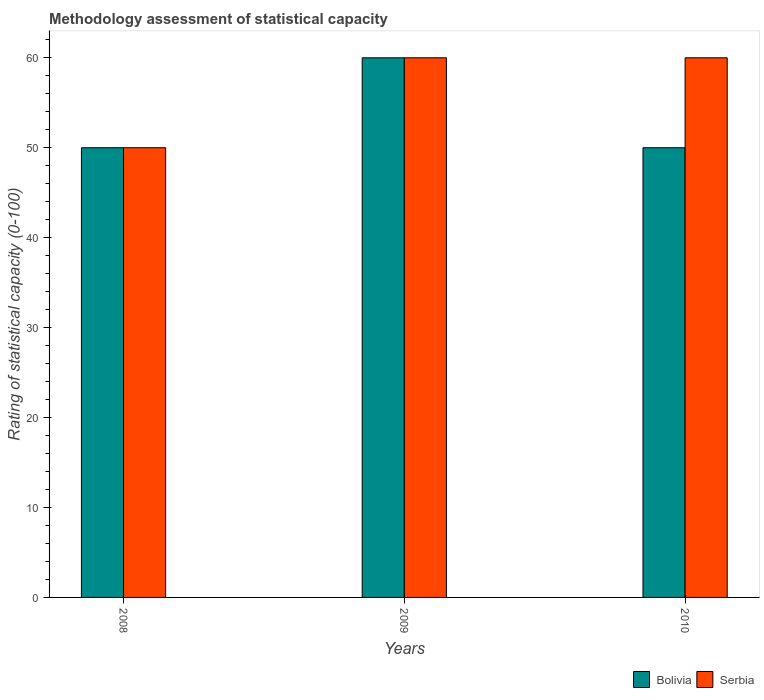How many bars are there on the 1st tick from the left?
Your answer should be very brief. 2. What is the label of the 3rd group of bars from the left?
Your response must be concise. 2010. In how many cases, is the number of bars for a given year not equal to the number of legend labels?
Provide a succinct answer. 0. What is the rating of statistical capacity in Bolivia in 2008?
Your answer should be compact. 50. Across all years, what is the maximum rating of statistical capacity in Bolivia?
Your response must be concise. 60. Across all years, what is the minimum rating of statistical capacity in Serbia?
Give a very brief answer. 50. In which year was the rating of statistical capacity in Serbia maximum?
Offer a terse response. 2009. What is the total rating of statistical capacity in Bolivia in the graph?
Give a very brief answer. 160. What is the difference between the rating of statistical capacity in Bolivia in 2008 and the rating of statistical capacity in Serbia in 2009?
Provide a succinct answer. -10. What is the average rating of statistical capacity in Serbia per year?
Provide a succinct answer. 56.67. In the year 2010, what is the difference between the rating of statistical capacity in Bolivia and rating of statistical capacity in Serbia?
Offer a very short reply. -10. What is the ratio of the rating of statistical capacity in Serbia in 2009 to that in 2010?
Ensure brevity in your answer.  1. Is the rating of statistical capacity in Bolivia in 2008 less than that in 2009?
Offer a terse response. Yes. What is the difference between the highest and the lowest rating of statistical capacity in Serbia?
Provide a succinct answer. 10. Is the sum of the rating of statistical capacity in Serbia in 2008 and 2009 greater than the maximum rating of statistical capacity in Bolivia across all years?
Make the answer very short. Yes. What does the 1st bar from the left in 2009 represents?
Provide a short and direct response. Bolivia. What does the 1st bar from the right in 2010 represents?
Your answer should be compact. Serbia. How many years are there in the graph?
Ensure brevity in your answer.  3. What is the difference between two consecutive major ticks on the Y-axis?
Provide a short and direct response. 10. Does the graph contain any zero values?
Your response must be concise. No. Where does the legend appear in the graph?
Make the answer very short. Bottom right. How many legend labels are there?
Your answer should be compact. 2. How are the legend labels stacked?
Ensure brevity in your answer.  Horizontal. What is the title of the graph?
Ensure brevity in your answer.  Methodology assessment of statistical capacity. Does "Least developed countries" appear as one of the legend labels in the graph?
Give a very brief answer. No. What is the label or title of the X-axis?
Your answer should be compact. Years. What is the label or title of the Y-axis?
Offer a very short reply. Rating of statistical capacity (0-100). What is the Rating of statistical capacity (0-100) in Bolivia in 2008?
Give a very brief answer. 50. Across all years, what is the maximum Rating of statistical capacity (0-100) in Serbia?
Offer a very short reply. 60. Across all years, what is the minimum Rating of statistical capacity (0-100) of Bolivia?
Make the answer very short. 50. What is the total Rating of statistical capacity (0-100) in Bolivia in the graph?
Keep it short and to the point. 160. What is the total Rating of statistical capacity (0-100) in Serbia in the graph?
Offer a very short reply. 170. What is the difference between the Rating of statistical capacity (0-100) in Serbia in 2008 and that in 2009?
Offer a terse response. -10. What is the difference between the Rating of statistical capacity (0-100) in Serbia in 2008 and that in 2010?
Your answer should be very brief. -10. What is the difference between the Rating of statistical capacity (0-100) of Bolivia in 2009 and that in 2010?
Make the answer very short. 10. What is the difference between the Rating of statistical capacity (0-100) in Serbia in 2009 and that in 2010?
Provide a succinct answer. 0. What is the difference between the Rating of statistical capacity (0-100) in Bolivia in 2009 and the Rating of statistical capacity (0-100) in Serbia in 2010?
Provide a short and direct response. 0. What is the average Rating of statistical capacity (0-100) of Bolivia per year?
Your answer should be compact. 53.33. What is the average Rating of statistical capacity (0-100) in Serbia per year?
Your answer should be very brief. 56.67. In the year 2008, what is the difference between the Rating of statistical capacity (0-100) of Bolivia and Rating of statistical capacity (0-100) of Serbia?
Ensure brevity in your answer.  0. In the year 2009, what is the difference between the Rating of statistical capacity (0-100) in Bolivia and Rating of statistical capacity (0-100) in Serbia?
Give a very brief answer. 0. What is the ratio of the Rating of statistical capacity (0-100) in Bolivia in 2008 to that in 2009?
Give a very brief answer. 0.83. What is the ratio of the Rating of statistical capacity (0-100) of Serbia in 2008 to that in 2010?
Provide a succinct answer. 0.83. What is the ratio of the Rating of statistical capacity (0-100) in Bolivia in 2009 to that in 2010?
Offer a very short reply. 1.2. What is the difference between the highest and the lowest Rating of statistical capacity (0-100) of Serbia?
Your response must be concise. 10. 